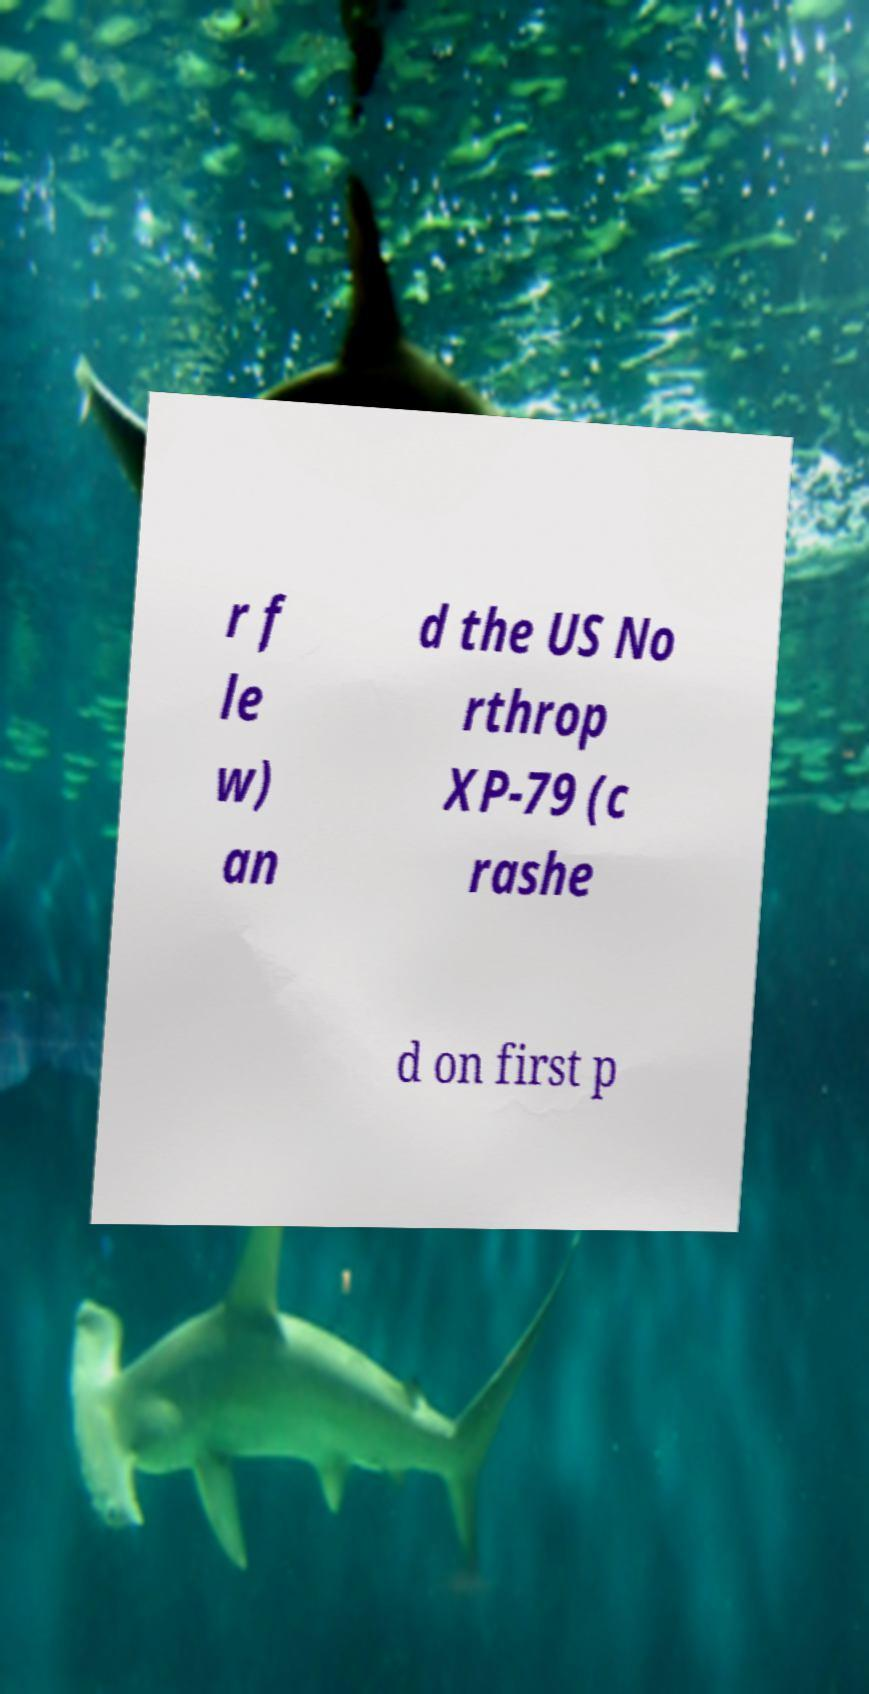What messages or text are displayed in this image? I need them in a readable, typed format. r f le w) an d the US No rthrop XP-79 (c rashe d on first p 